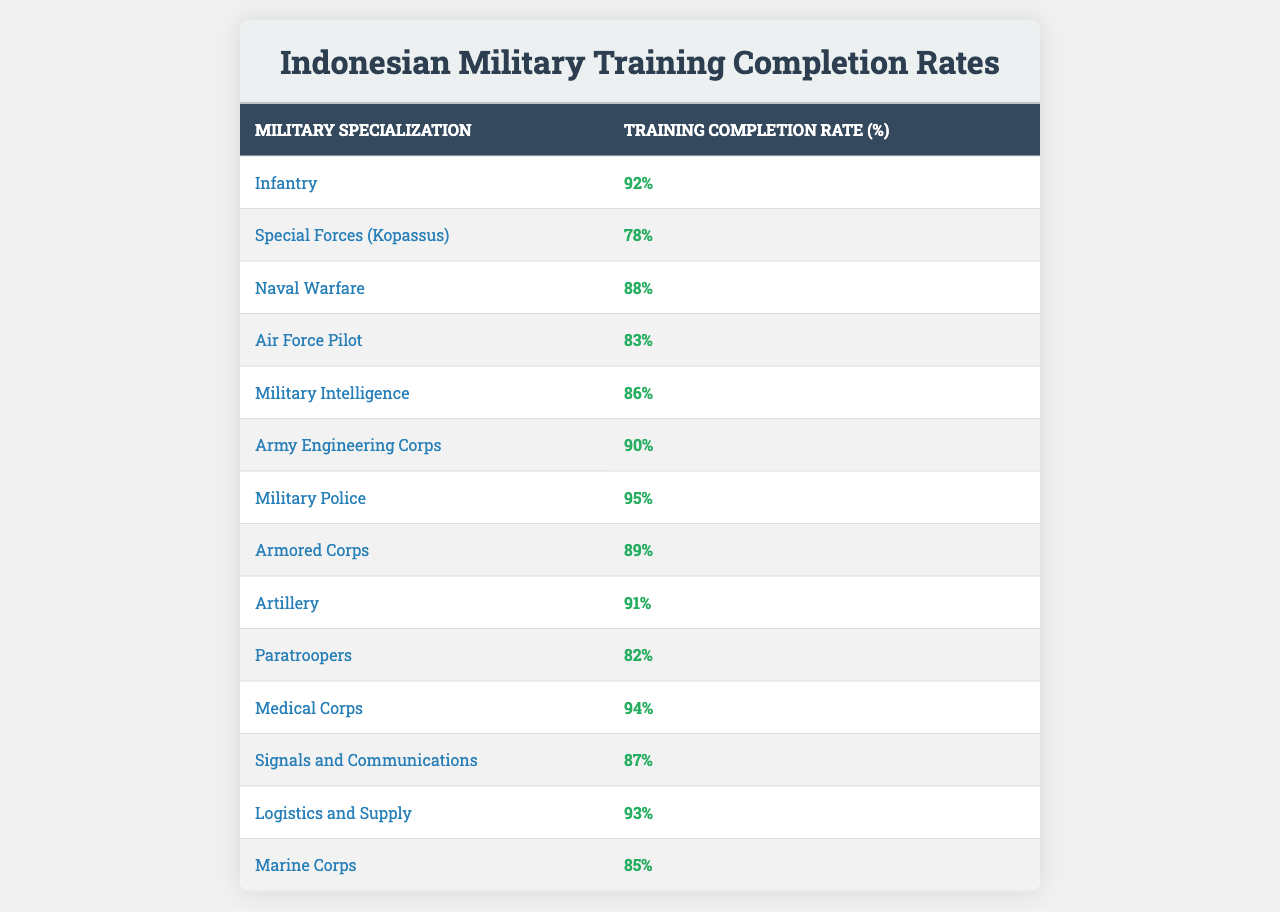What is the training completion rate for Military Police? The table lists Military Police with a training completion rate of 95%.
Answer: 95% Which military specialization has the highest training completion rate? By comparing the rates in the table, Military Police at 95% has the highest completion rate.
Answer: Military Police What is the training completion rate for Special Forces (Kopassus) compared to Marine Corps? Special Forces (Kopassus) has a completion rate of 78%, while Marine Corps has a 85% rate. Marine Corps has a higher completion rate than Special Forces.
Answer: Marine Corps has a higher rate How many military specializations have a training completion rate above 90%? The table shows four specializations: Military Police (95%), Medical Corps (94%), Logistics and Supply (93%), and Infantry (92%) with rates above 90%.
Answer: Four What is the average training completion rate for the listed military specializations? The completion rates are: 92, 78, 88, 83, 86, 90, 95, 89, 91, 82, 94, 87, 93, 85. Adding them gives 1180 and dividing by 14 (total specializations) gives an average of 84.29.
Answer: 84.29 Is the training completion rate for Air Force Pilot higher than that of Artillery? Air Force Pilot has a rate of 83% while Artillery has 91%, so Air Force Pilot's rate is not higher.
Answer: No What is the difference in training completion rates between the highest and lowest rates? The highest rate is 95% (Military Police) and the lowest is 78% (Special Forces). The difference is 95 - 78 = 17%.
Answer: 17% If you were to categorize specializations into high (above 90%) and low (below 80%) completion rates, how many would fall into each category? High completion rates: 6 specializations (Infantry, Military Police, Medical Corps, Logistics and Supply, Artillery, Armored Corps); Low completion rates: 3 specializations (Special Forces, Paratroopers, Marine Corps).
Answer: High: 6, Low: 3 Which military specialization has a completion rate that is closest to the average completion rate? The average is approximately 84.29%. The specialization closest to this is Air Force Pilot at 83%.
Answer: Air Force Pilot 